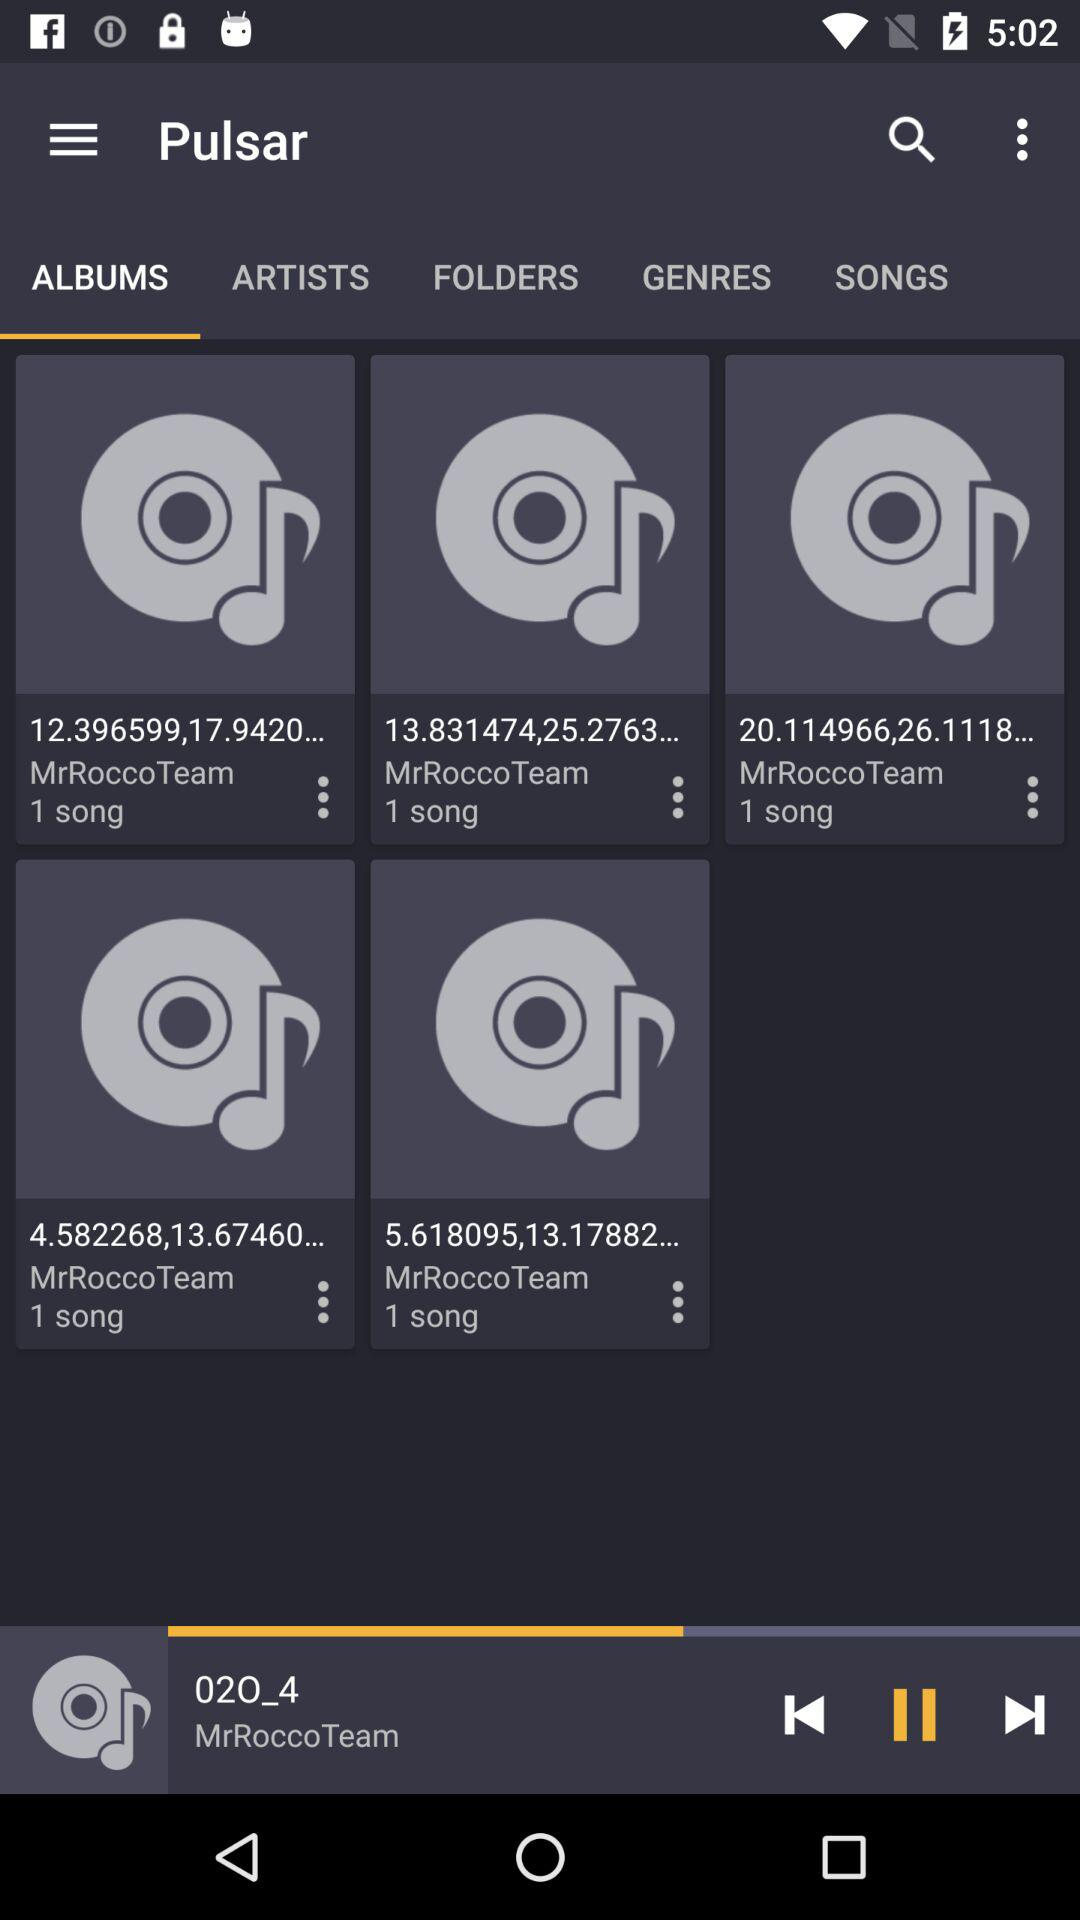What's the Music Composer Name?
When the provided information is insufficient, respond with <no answer>. <no answer> 